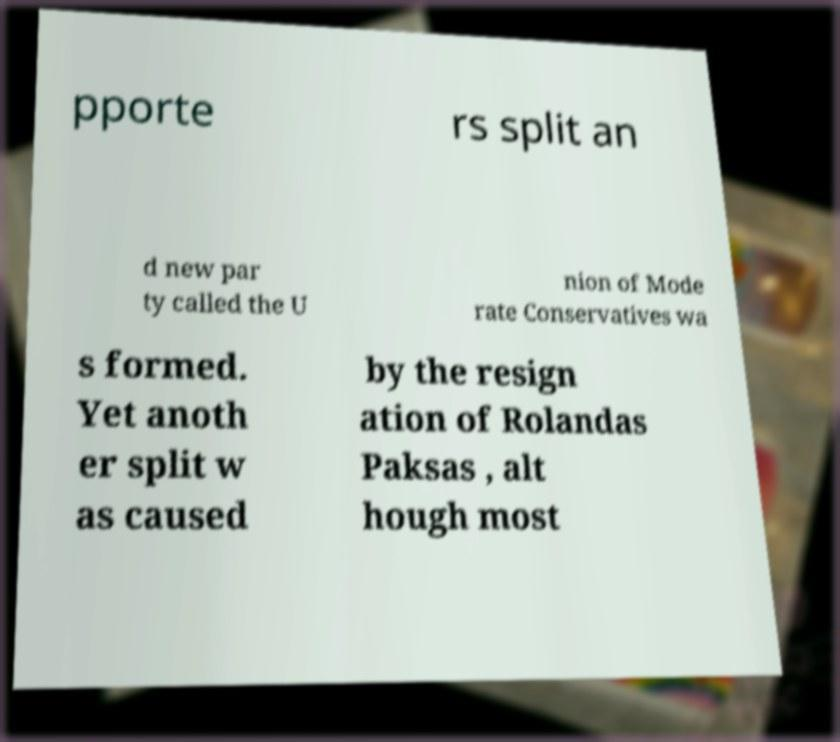Could you extract and type out the text from this image? pporte rs split an d new par ty called the U nion of Mode rate Conservatives wa s formed. Yet anoth er split w as caused by the resign ation of Rolandas Paksas , alt hough most 